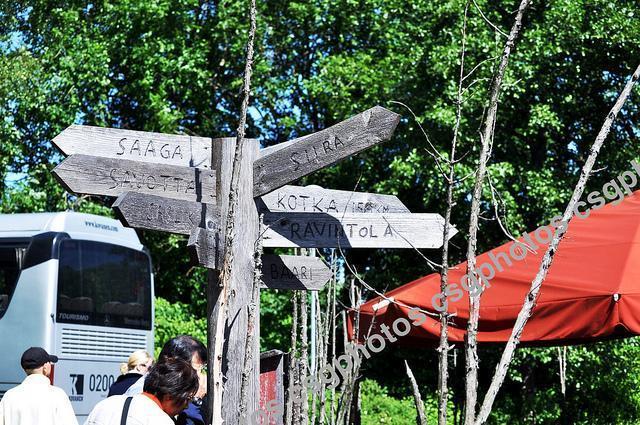How many signs are posted to the post?
Give a very brief answer. 9. How many people are in the picture?
Give a very brief answer. 2. 